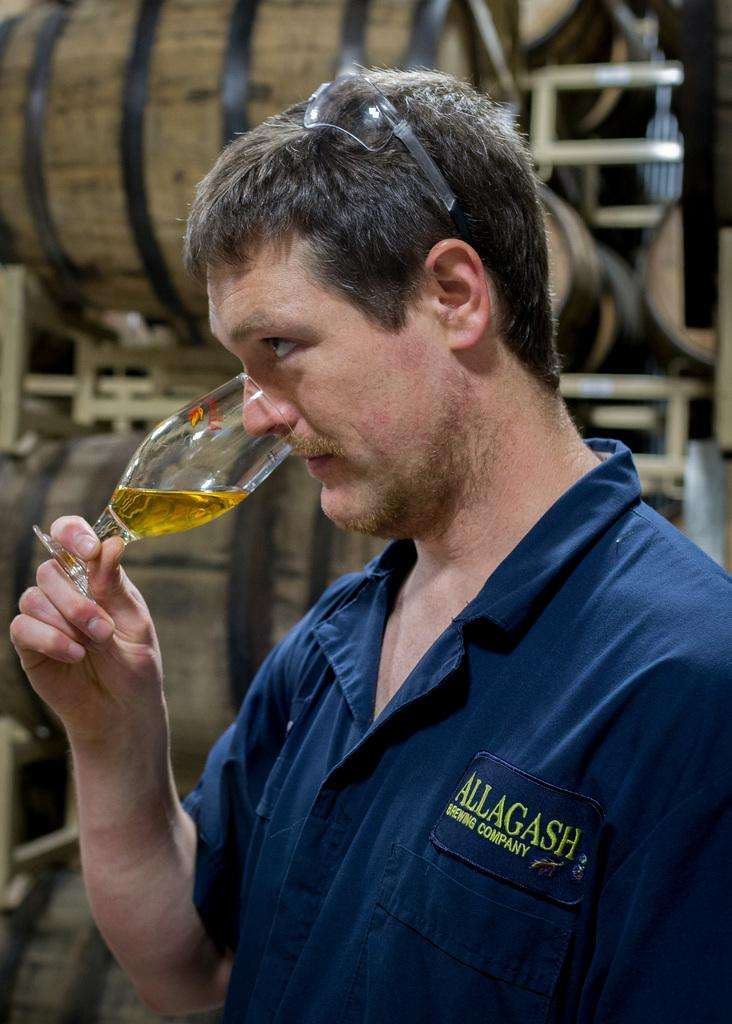Who is present in the image? There is a man in the image. What is the man holding in his hand? The man is holding a glass in his hand. What can be seen in the background of the image? There are wooden barrels in the background of the image. What type of shame can be seen on the man's face in the image? There is no indication of shame on the man's face in the image. How many giants are present in the image? There are no giants present in the image. 